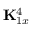Convert formula to latex. <formula><loc_0><loc_0><loc_500><loc_500>{ K } _ { 1 x } ^ { 4 }</formula> 